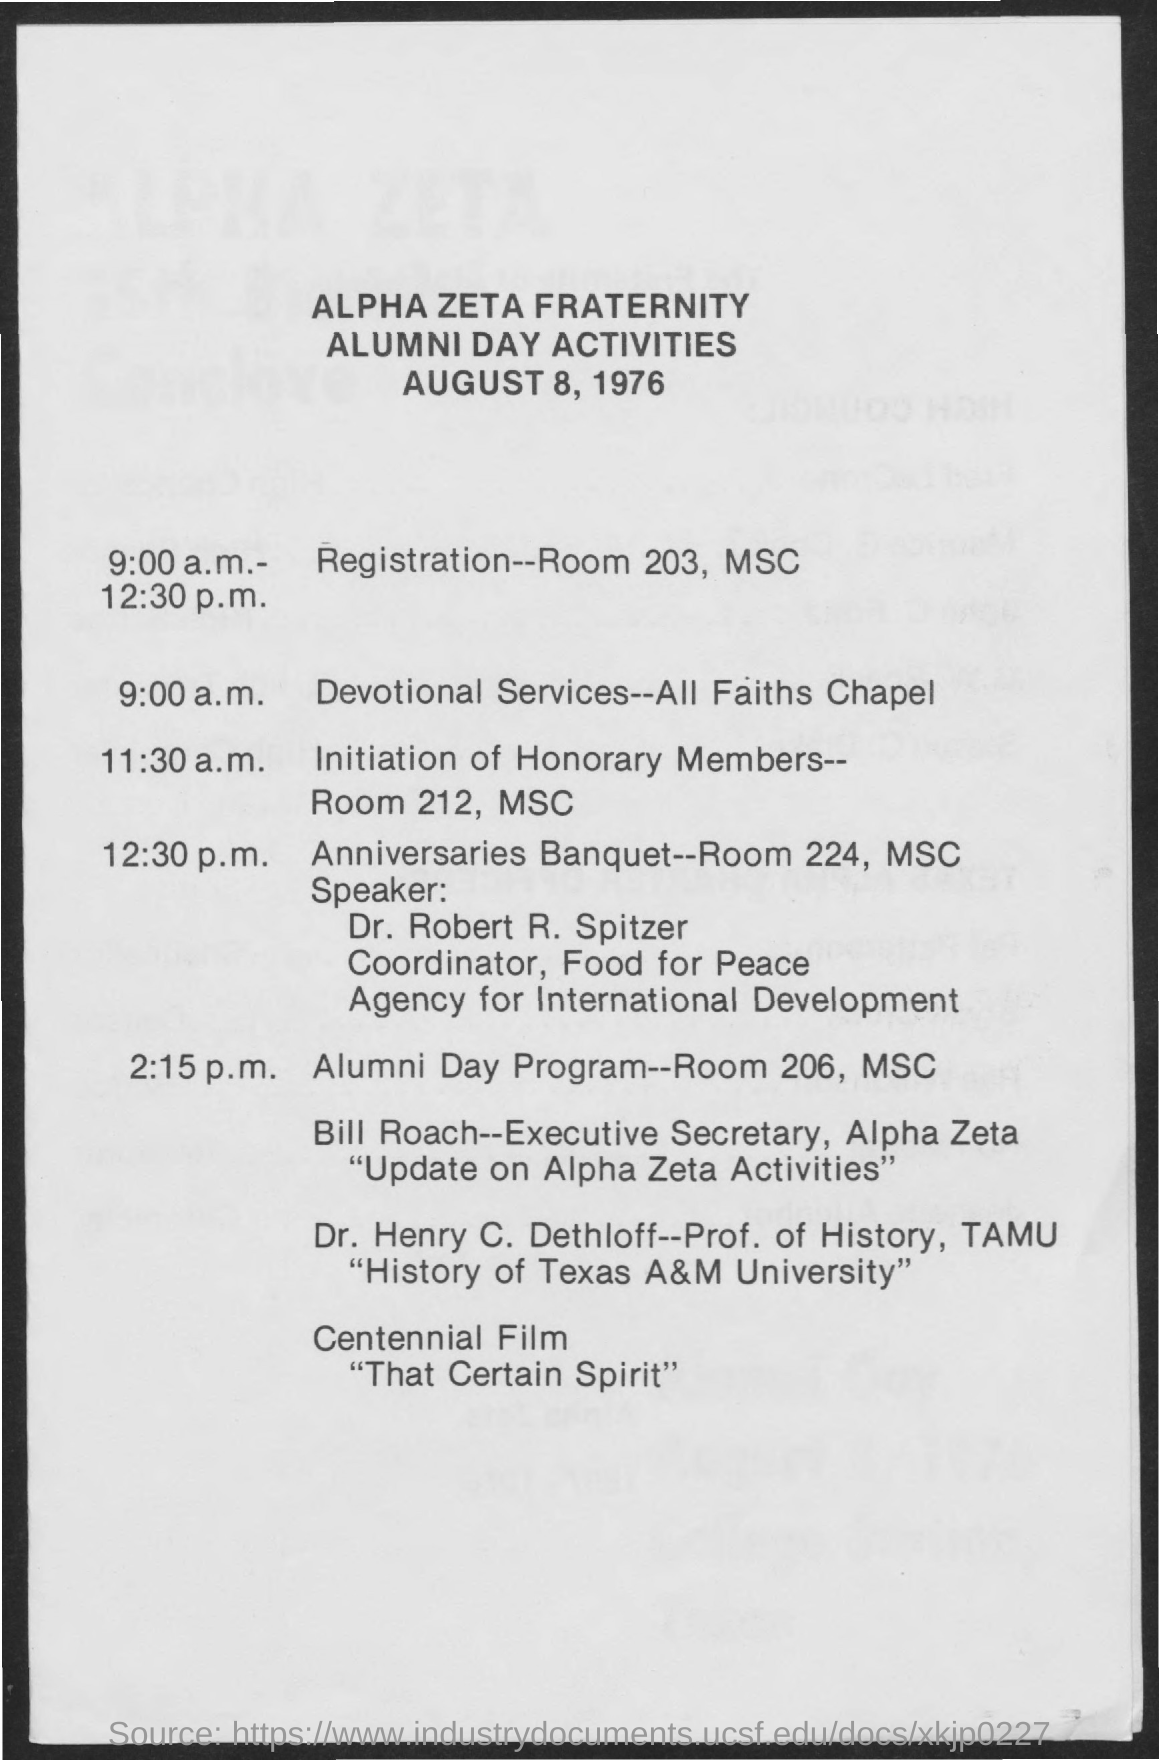What is the date on the document?
Offer a terse response. August 8, 1976. Where is the Registration?
Offer a very short reply. Room 203, MSC. Where is the Devotional services?
Provide a succinct answer. All faiths chapel. Where  is  the Initiation of Honorary Members?
Your response must be concise. Room 212, msc. 